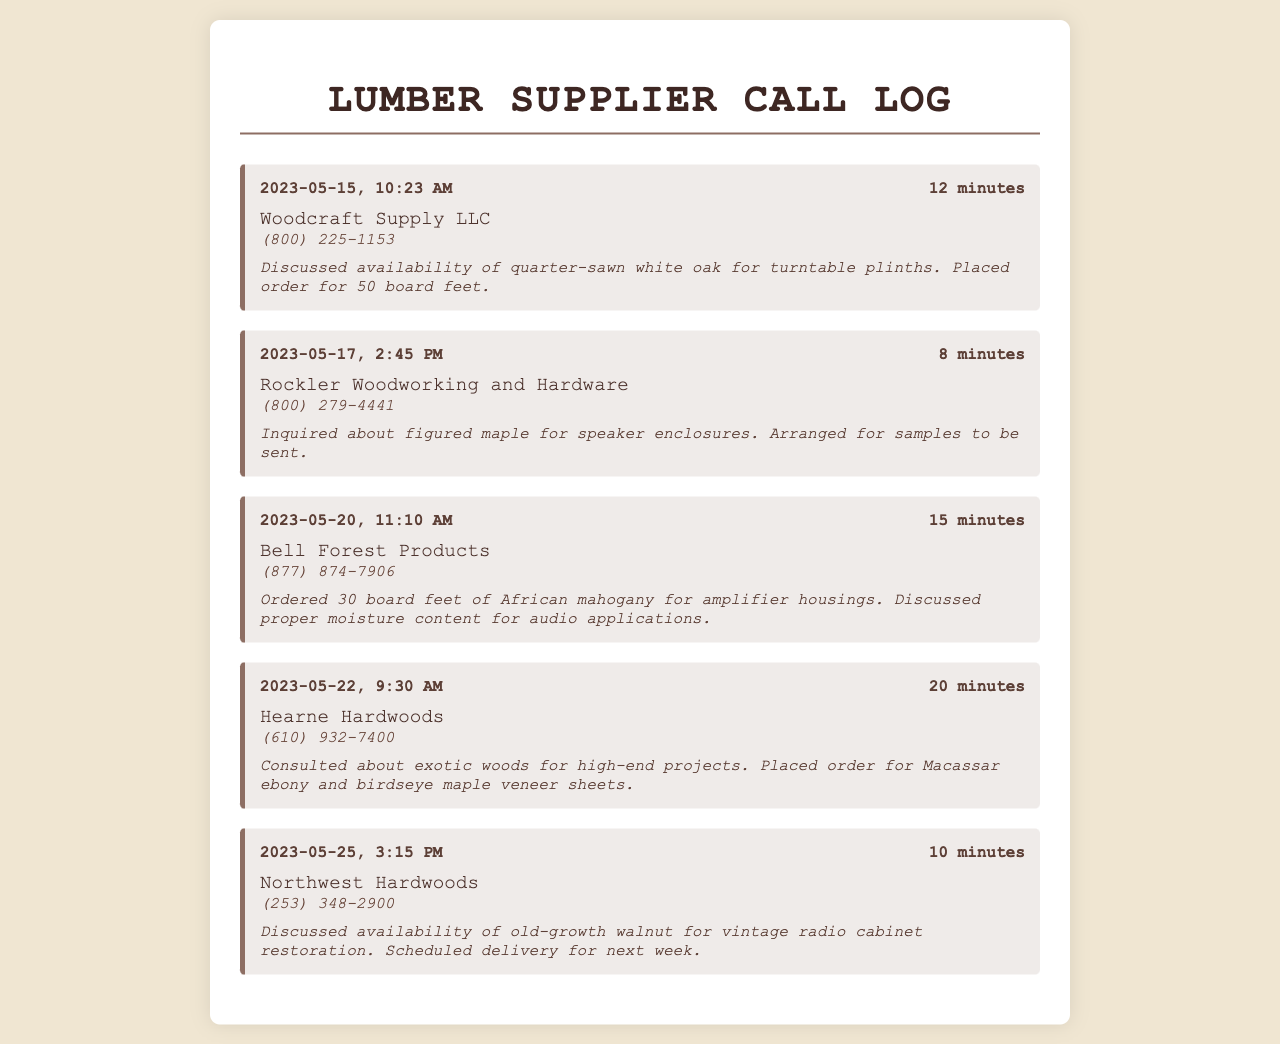what is the name of the first lumber supplier? The name of the first lumber supplier is listed as "Woodcraft Supply LLC" in the document.
Answer: Woodcraft Supply LLC what type of wood was ordered from Bell Forest Products? The type of wood ordered from Bell Forest Products is African mahogany, mentioned in the record.
Answer: African mahogany how many board feet of figured maple were arranged for samples? The document specifies that no quantity was ordered for figured maple, only samples were arranged.
Answer: Samples on what date was the consultation with Hearne Hardwoods? The consultation with Hearne Hardwoods took place on May 22, 2023, according to the record date.
Answer: May 22, 2023 how long was the call with Northwest Hardwoods? The duration of the call with Northwest Hardwoods was 10 minutes, as stated in the record.
Answer: 10 minutes what was discussed regarding old-growth walnut? The discussion about old-growth walnut involved its availability for a specific project related to vintage radios.
Answer: Availability how much quarter-sawn white oak was ordered? The document mentions that an order for 50 board feet of quarter-sawn white oak was placed.
Answer: 50 board feet who is the contact for Rockler Woodworking and Hardware? The document does not provide a specific contact name for Rockler Woodworking and Hardware, only the company name and phone number.
Answer: Not specified what specific moisture content was discussed with Bell Forest Products? The record states that proper moisture content for audio applications was discussed in relation to the order.
Answer: Proper moisture content 